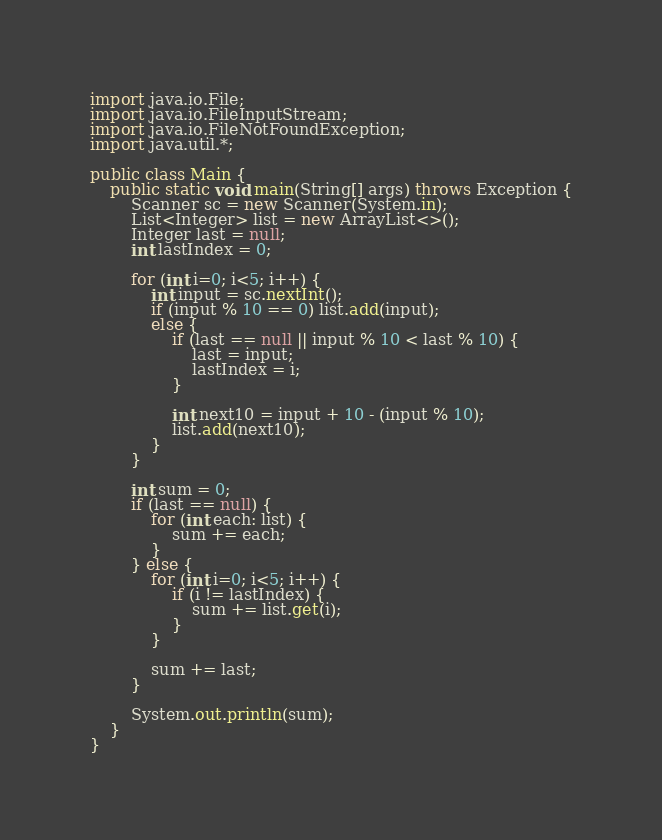Convert code to text. <code><loc_0><loc_0><loc_500><loc_500><_Java_>import java.io.File;
import java.io.FileInputStream;
import java.io.FileNotFoundException;
import java.util.*;

public class Main {
    public static void main(String[] args) throws Exception {
        Scanner sc = new Scanner(System.in);
        List<Integer> list = new ArrayList<>();
        Integer last = null;
        int lastIndex = 0;

        for (int i=0; i<5; i++) {
            int input = sc.nextInt();
            if (input % 10 == 0) list.add(input);
            else {
                if (last == null || input % 10 < last % 10) {
                    last = input;
                    lastIndex = i;
                }

                int next10 = input + 10 - (input % 10);
                list.add(next10);
            }
        }

        int sum = 0;
        if (last == null) {
            for (int each: list) {
                sum += each;
            }
        } else {
            for (int i=0; i<5; i++) {
                if (i != lastIndex) {
                    sum += list.get(i);
                }
            }

            sum += last;
        }

        System.out.println(sum);
    }
}
</code> 